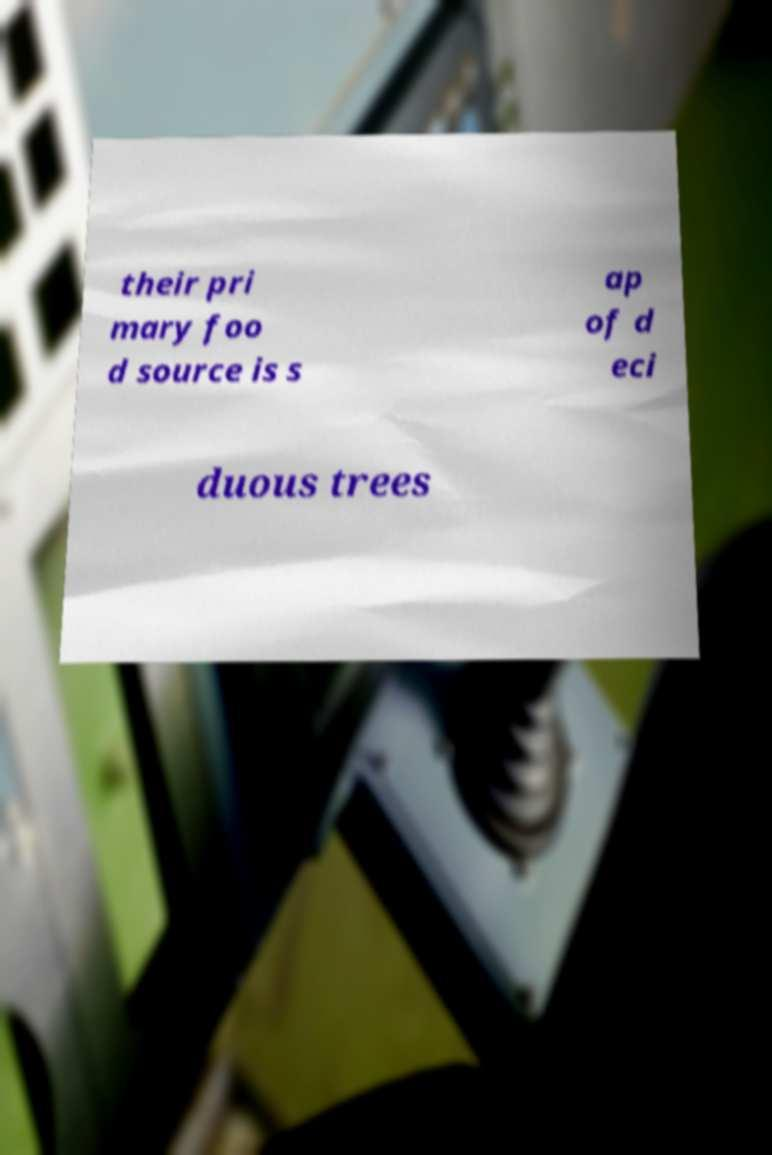Could you assist in decoding the text presented in this image and type it out clearly? their pri mary foo d source is s ap of d eci duous trees 